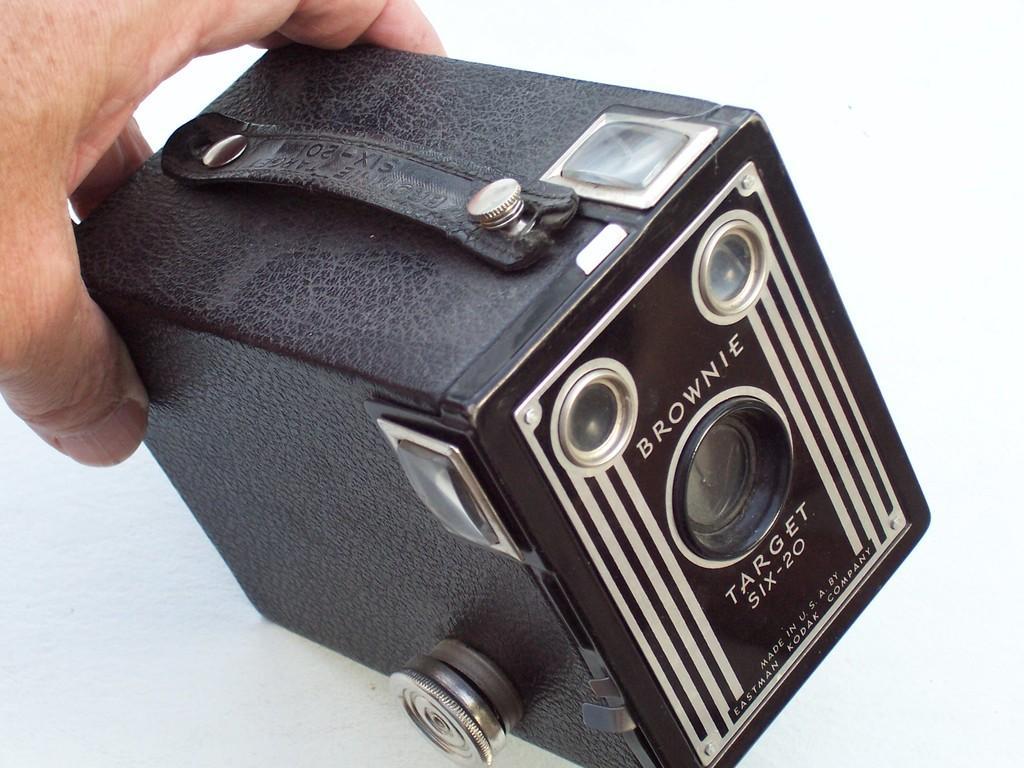In one or two sentences, can you explain what this image depicts? In this image we can see a person's hand holding a vintage camera. 